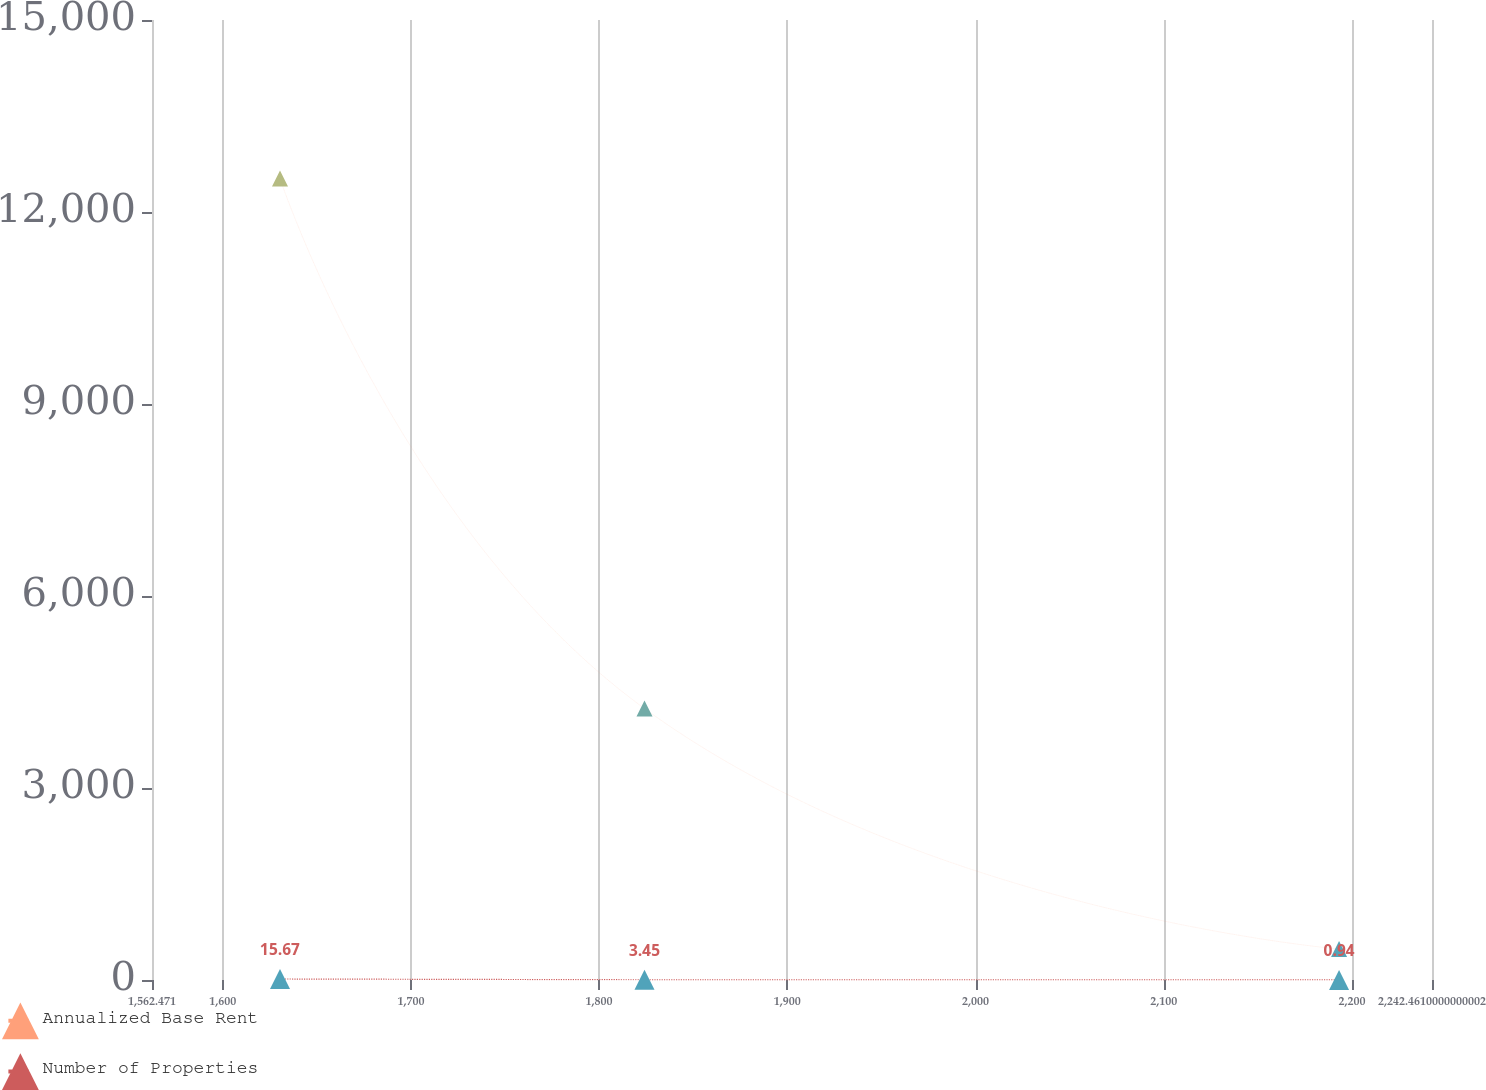<chart> <loc_0><loc_0><loc_500><loc_500><line_chart><ecel><fcel>Annualized Base Rent<fcel>Number of Properties<nl><fcel>1630.47<fcel>12522.3<fcel>15.67<nl><fcel>1824.1<fcel>4241.83<fcel>3.45<nl><fcel>2193.1<fcel>484.65<fcel>0.94<nl><fcel>2251.78<fcel>27154.1<fcel>26.07<nl><fcel>2310.46<fcel>38056.4<fcel>12.83<nl></chart> 